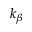Convert formula to latex. <formula><loc_0><loc_0><loc_500><loc_500>k _ { \beta }</formula> 